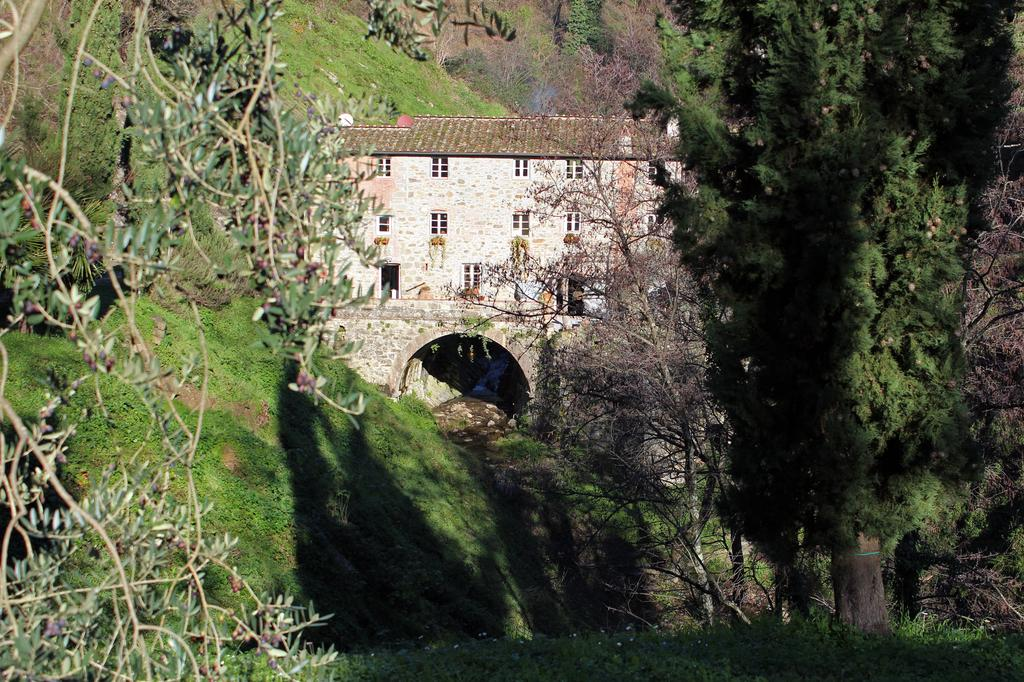What is the main subject of the image? The main subject of the image is a building. What can be seen around the building? There are trees, plants, and grass around the building. What type of drink is being served in the glass on the building's roof? There is no glass or drink present on the building's roof in the image. 